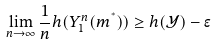Convert formula to latex. <formula><loc_0><loc_0><loc_500><loc_500>\lim _ { n \to \infty } \frac { 1 } { n } h ( Y _ { 1 } ^ { n } ( m ^ { ^ { * } } ) ) \geq h ( \mathcal { Y } ) - \epsilon</formula> 